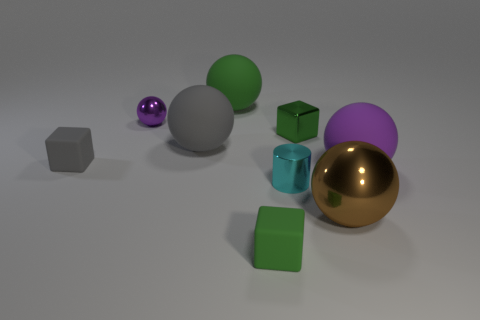How many spheres are either large purple objects or small matte things?
Offer a terse response. 1. What color is the shiny cylinder?
Ensure brevity in your answer.  Cyan. There is a matte ball that is behind the tiny green shiny cube; does it have the same size as the sphere that is on the right side of the large metal sphere?
Make the answer very short. Yes. Are there fewer cyan metal spheres than matte blocks?
Keep it short and to the point. Yes. How many green matte cubes are behind the tiny green metal object?
Offer a terse response. 0. What is the material of the big purple object?
Your answer should be very brief. Rubber. Do the cylinder and the tiny metallic ball have the same color?
Keep it short and to the point. No. Is the number of metallic objects that are left of the tiny gray thing less than the number of green balls?
Your answer should be compact. Yes. What is the color of the rubber ball behind the tiny purple shiny ball?
Make the answer very short. Green. What is the shape of the purple shiny thing?
Ensure brevity in your answer.  Sphere. 